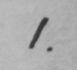What does this handwritten line say? 1 . 